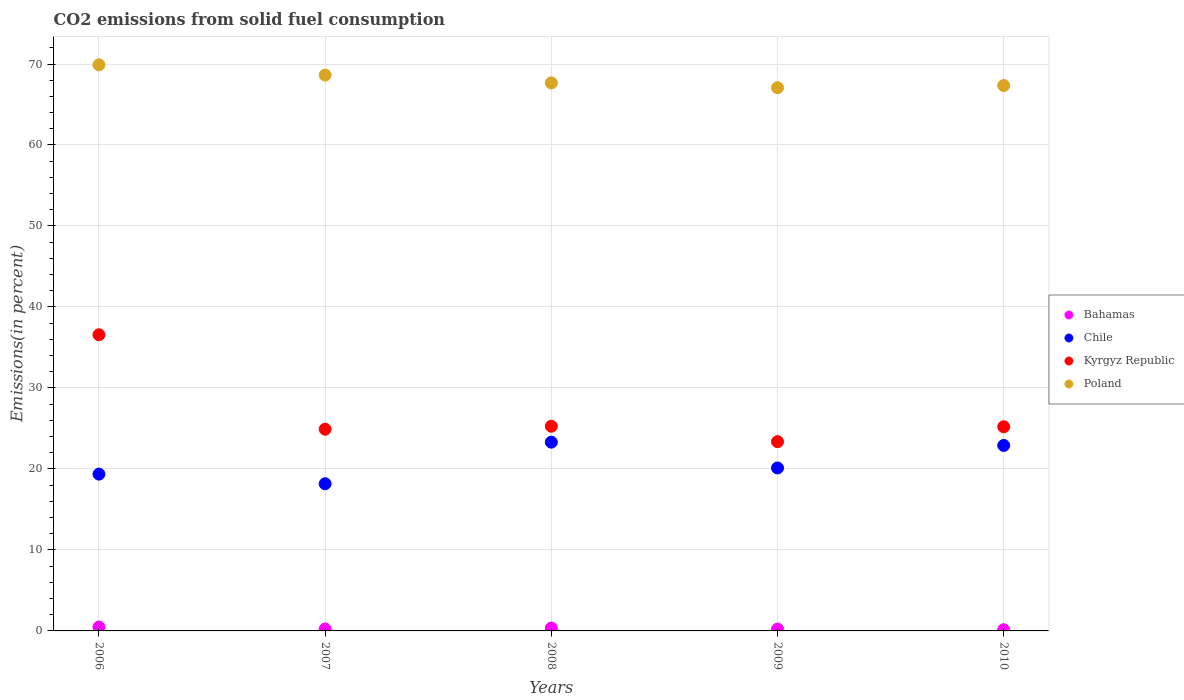What is the total CO2 emitted in Bahamas in 2007?
Offer a terse response. 0.24. Across all years, what is the maximum total CO2 emitted in Poland?
Your answer should be very brief. 69.9. Across all years, what is the minimum total CO2 emitted in Poland?
Keep it short and to the point. 67.08. In which year was the total CO2 emitted in Bahamas minimum?
Your response must be concise. 2010. What is the total total CO2 emitted in Kyrgyz Republic in the graph?
Provide a short and direct response. 135.33. What is the difference between the total CO2 emitted in Bahamas in 2006 and that in 2007?
Ensure brevity in your answer.  0.24. What is the difference between the total CO2 emitted in Kyrgyz Republic in 2008 and the total CO2 emitted in Bahamas in 2007?
Provide a short and direct response. 25.04. What is the average total CO2 emitted in Bahamas per year?
Offer a terse response. 0.29. In the year 2007, what is the difference between the total CO2 emitted in Poland and total CO2 emitted in Chile?
Offer a very short reply. 50.46. In how many years, is the total CO2 emitted in Poland greater than 4 %?
Your answer should be compact. 5. What is the ratio of the total CO2 emitted in Bahamas in 2006 to that in 2007?
Keep it short and to the point. 2.03. Is the difference between the total CO2 emitted in Poland in 2007 and 2009 greater than the difference between the total CO2 emitted in Chile in 2007 and 2009?
Make the answer very short. Yes. What is the difference between the highest and the second highest total CO2 emitted in Kyrgyz Republic?
Give a very brief answer. 11.3. What is the difference between the highest and the lowest total CO2 emitted in Poland?
Offer a very short reply. 2.82. In how many years, is the total CO2 emitted in Bahamas greater than the average total CO2 emitted in Bahamas taken over all years?
Ensure brevity in your answer.  2. Is the sum of the total CO2 emitted in Chile in 2008 and 2009 greater than the maximum total CO2 emitted in Poland across all years?
Your response must be concise. No. Is it the case that in every year, the sum of the total CO2 emitted in Bahamas and total CO2 emitted in Chile  is greater than the sum of total CO2 emitted in Poland and total CO2 emitted in Kyrgyz Republic?
Your answer should be very brief. No. Is it the case that in every year, the sum of the total CO2 emitted in Chile and total CO2 emitted in Kyrgyz Republic  is greater than the total CO2 emitted in Bahamas?
Keep it short and to the point. Yes. Is the total CO2 emitted in Poland strictly greater than the total CO2 emitted in Bahamas over the years?
Your answer should be very brief. Yes. How many dotlines are there?
Give a very brief answer. 4. Are the values on the major ticks of Y-axis written in scientific E-notation?
Offer a terse response. No. Where does the legend appear in the graph?
Your answer should be very brief. Center right. How are the legend labels stacked?
Give a very brief answer. Vertical. What is the title of the graph?
Provide a short and direct response. CO2 emissions from solid fuel consumption. What is the label or title of the X-axis?
Offer a very short reply. Years. What is the label or title of the Y-axis?
Provide a succinct answer. Emissions(in percent). What is the Emissions(in percent) of Bahamas in 2006?
Make the answer very short. 0.48. What is the Emissions(in percent) of Chile in 2006?
Keep it short and to the point. 19.36. What is the Emissions(in percent) in Kyrgyz Republic in 2006?
Your answer should be compact. 36.57. What is the Emissions(in percent) of Poland in 2006?
Provide a short and direct response. 69.9. What is the Emissions(in percent) in Bahamas in 2007?
Ensure brevity in your answer.  0.24. What is the Emissions(in percent) in Chile in 2007?
Your answer should be compact. 18.17. What is the Emissions(in percent) of Kyrgyz Republic in 2007?
Provide a short and direct response. 24.91. What is the Emissions(in percent) of Poland in 2007?
Offer a terse response. 68.63. What is the Emissions(in percent) of Bahamas in 2008?
Give a very brief answer. 0.35. What is the Emissions(in percent) in Chile in 2008?
Provide a short and direct response. 23.31. What is the Emissions(in percent) in Kyrgyz Republic in 2008?
Your answer should be very brief. 25.27. What is the Emissions(in percent) in Poland in 2008?
Keep it short and to the point. 67.67. What is the Emissions(in percent) in Bahamas in 2009?
Offer a very short reply. 0.22. What is the Emissions(in percent) of Chile in 2009?
Offer a terse response. 20.12. What is the Emissions(in percent) in Kyrgyz Republic in 2009?
Ensure brevity in your answer.  23.37. What is the Emissions(in percent) of Poland in 2009?
Your response must be concise. 67.08. What is the Emissions(in percent) of Bahamas in 2010?
Ensure brevity in your answer.  0.15. What is the Emissions(in percent) of Chile in 2010?
Your answer should be compact. 22.9. What is the Emissions(in percent) of Kyrgyz Republic in 2010?
Keep it short and to the point. 25.21. What is the Emissions(in percent) in Poland in 2010?
Give a very brief answer. 67.34. Across all years, what is the maximum Emissions(in percent) in Bahamas?
Make the answer very short. 0.48. Across all years, what is the maximum Emissions(in percent) in Chile?
Provide a succinct answer. 23.31. Across all years, what is the maximum Emissions(in percent) of Kyrgyz Republic?
Your response must be concise. 36.57. Across all years, what is the maximum Emissions(in percent) in Poland?
Offer a very short reply. 69.9. Across all years, what is the minimum Emissions(in percent) in Bahamas?
Ensure brevity in your answer.  0.15. Across all years, what is the minimum Emissions(in percent) in Chile?
Make the answer very short. 18.17. Across all years, what is the minimum Emissions(in percent) of Kyrgyz Republic?
Ensure brevity in your answer.  23.37. Across all years, what is the minimum Emissions(in percent) in Poland?
Give a very brief answer. 67.08. What is the total Emissions(in percent) in Bahamas in the graph?
Your answer should be very brief. 1.44. What is the total Emissions(in percent) in Chile in the graph?
Your answer should be compact. 103.87. What is the total Emissions(in percent) in Kyrgyz Republic in the graph?
Ensure brevity in your answer.  135.33. What is the total Emissions(in percent) of Poland in the graph?
Your response must be concise. 340.62. What is the difference between the Emissions(in percent) of Bahamas in 2006 and that in 2007?
Your answer should be compact. 0.24. What is the difference between the Emissions(in percent) of Chile in 2006 and that in 2007?
Give a very brief answer. 1.19. What is the difference between the Emissions(in percent) in Kyrgyz Republic in 2006 and that in 2007?
Your answer should be compact. 11.66. What is the difference between the Emissions(in percent) in Poland in 2006 and that in 2007?
Provide a short and direct response. 1.27. What is the difference between the Emissions(in percent) in Bahamas in 2006 and that in 2008?
Ensure brevity in your answer.  0.13. What is the difference between the Emissions(in percent) in Chile in 2006 and that in 2008?
Your response must be concise. -3.95. What is the difference between the Emissions(in percent) of Kyrgyz Republic in 2006 and that in 2008?
Provide a short and direct response. 11.3. What is the difference between the Emissions(in percent) of Poland in 2006 and that in 2008?
Your answer should be very brief. 2.23. What is the difference between the Emissions(in percent) in Bahamas in 2006 and that in 2009?
Ensure brevity in your answer.  0.26. What is the difference between the Emissions(in percent) in Chile in 2006 and that in 2009?
Ensure brevity in your answer.  -0.76. What is the difference between the Emissions(in percent) of Kyrgyz Republic in 2006 and that in 2009?
Provide a short and direct response. 13.2. What is the difference between the Emissions(in percent) of Poland in 2006 and that in 2009?
Your answer should be compact. 2.82. What is the difference between the Emissions(in percent) in Bahamas in 2006 and that in 2010?
Your answer should be compact. 0.33. What is the difference between the Emissions(in percent) in Chile in 2006 and that in 2010?
Provide a short and direct response. -3.54. What is the difference between the Emissions(in percent) of Kyrgyz Republic in 2006 and that in 2010?
Offer a very short reply. 11.36. What is the difference between the Emissions(in percent) of Poland in 2006 and that in 2010?
Offer a very short reply. 2.56. What is the difference between the Emissions(in percent) in Bahamas in 2007 and that in 2008?
Offer a very short reply. -0.11. What is the difference between the Emissions(in percent) in Chile in 2007 and that in 2008?
Your response must be concise. -5.14. What is the difference between the Emissions(in percent) of Kyrgyz Republic in 2007 and that in 2008?
Give a very brief answer. -0.37. What is the difference between the Emissions(in percent) of Poland in 2007 and that in 2008?
Your answer should be very brief. 0.97. What is the difference between the Emissions(in percent) in Bahamas in 2007 and that in 2009?
Provide a short and direct response. 0.01. What is the difference between the Emissions(in percent) in Chile in 2007 and that in 2009?
Your answer should be very brief. -1.95. What is the difference between the Emissions(in percent) of Kyrgyz Republic in 2007 and that in 2009?
Your response must be concise. 1.54. What is the difference between the Emissions(in percent) in Poland in 2007 and that in 2009?
Keep it short and to the point. 1.56. What is the difference between the Emissions(in percent) of Bahamas in 2007 and that in 2010?
Your answer should be very brief. 0.09. What is the difference between the Emissions(in percent) in Chile in 2007 and that in 2010?
Offer a terse response. -4.73. What is the difference between the Emissions(in percent) in Kyrgyz Republic in 2007 and that in 2010?
Give a very brief answer. -0.3. What is the difference between the Emissions(in percent) in Poland in 2007 and that in 2010?
Give a very brief answer. 1.29. What is the difference between the Emissions(in percent) in Bahamas in 2008 and that in 2009?
Your answer should be very brief. 0.13. What is the difference between the Emissions(in percent) in Chile in 2008 and that in 2009?
Your answer should be very brief. 3.19. What is the difference between the Emissions(in percent) of Kyrgyz Republic in 2008 and that in 2009?
Give a very brief answer. 1.9. What is the difference between the Emissions(in percent) of Poland in 2008 and that in 2009?
Provide a succinct answer. 0.59. What is the difference between the Emissions(in percent) of Bahamas in 2008 and that in 2010?
Your answer should be compact. 0.2. What is the difference between the Emissions(in percent) in Chile in 2008 and that in 2010?
Your answer should be very brief. 0.41. What is the difference between the Emissions(in percent) of Kyrgyz Republic in 2008 and that in 2010?
Your response must be concise. 0.07. What is the difference between the Emissions(in percent) of Poland in 2008 and that in 2010?
Your answer should be compact. 0.32. What is the difference between the Emissions(in percent) in Bahamas in 2009 and that in 2010?
Provide a short and direct response. 0.07. What is the difference between the Emissions(in percent) in Chile in 2009 and that in 2010?
Give a very brief answer. -2.78. What is the difference between the Emissions(in percent) of Kyrgyz Republic in 2009 and that in 2010?
Your response must be concise. -1.84. What is the difference between the Emissions(in percent) in Poland in 2009 and that in 2010?
Your response must be concise. -0.27. What is the difference between the Emissions(in percent) of Bahamas in 2006 and the Emissions(in percent) of Chile in 2007?
Offer a terse response. -17.69. What is the difference between the Emissions(in percent) in Bahamas in 2006 and the Emissions(in percent) in Kyrgyz Republic in 2007?
Ensure brevity in your answer.  -24.42. What is the difference between the Emissions(in percent) in Bahamas in 2006 and the Emissions(in percent) in Poland in 2007?
Your answer should be very brief. -68.15. What is the difference between the Emissions(in percent) of Chile in 2006 and the Emissions(in percent) of Kyrgyz Republic in 2007?
Ensure brevity in your answer.  -5.55. What is the difference between the Emissions(in percent) of Chile in 2006 and the Emissions(in percent) of Poland in 2007?
Ensure brevity in your answer.  -49.27. What is the difference between the Emissions(in percent) in Kyrgyz Republic in 2006 and the Emissions(in percent) in Poland in 2007?
Your answer should be compact. -32.06. What is the difference between the Emissions(in percent) of Bahamas in 2006 and the Emissions(in percent) of Chile in 2008?
Offer a very short reply. -22.83. What is the difference between the Emissions(in percent) in Bahamas in 2006 and the Emissions(in percent) in Kyrgyz Republic in 2008?
Give a very brief answer. -24.79. What is the difference between the Emissions(in percent) of Bahamas in 2006 and the Emissions(in percent) of Poland in 2008?
Ensure brevity in your answer.  -67.18. What is the difference between the Emissions(in percent) of Chile in 2006 and the Emissions(in percent) of Kyrgyz Republic in 2008?
Ensure brevity in your answer.  -5.91. What is the difference between the Emissions(in percent) in Chile in 2006 and the Emissions(in percent) in Poland in 2008?
Offer a very short reply. -48.31. What is the difference between the Emissions(in percent) in Kyrgyz Republic in 2006 and the Emissions(in percent) in Poland in 2008?
Your response must be concise. -31.1. What is the difference between the Emissions(in percent) in Bahamas in 2006 and the Emissions(in percent) in Chile in 2009?
Provide a short and direct response. -19.64. What is the difference between the Emissions(in percent) in Bahamas in 2006 and the Emissions(in percent) in Kyrgyz Republic in 2009?
Keep it short and to the point. -22.89. What is the difference between the Emissions(in percent) in Bahamas in 2006 and the Emissions(in percent) in Poland in 2009?
Keep it short and to the point. -66.59. What is the difference between the Emissions(in percent) in Chile in 2006 and the Emissions(in percent) in Kyrgyz Republic in 2009?
Your answer should be compact. -4.01. What is the difference between the Emissions(in percent) of Chile in 2006 and the Emissions(in percent) of Poland in 2009?
Offer a terse response. -47.72. What is the difference between the Emissions(in percent) in Kyrgyz Republic in 2006 and the Emissions(in percent) in Poland in 2009?
Provide a succinct answer. -30.51. What is the difference between the Emissions(in percent) in Bahamas in 2006 and the Emissions(in percent) in Chile in 2010?
Ensure brevity in your answer.  -22.42. What is the difference between the Emissions(in percent) of Bahamas in 2006 and the Emissions(in percent) of Kyrgyz Republic in 2010?
Provide a succinct answer. -24.73. What is the difference between the Emissions(in percent) of Bahamas in 2006 and the Emissions(in percent) of Poland in 2010?
Give a very brief answer. -66.86. What is the difference between the Emissions(in percent) in Chile in 2006 and the Emissions(in percent) in Kyrgyz Republic in 2010?
Keep it short and to the point. -5.85. What is the difference between the Emissions(in percent) of Chile in 2006 and the Emissions(in percent) of Poland in 2010?
Ensure brevity in your answer.  -47.98. What is the difference between the Emissions(in percent) of Kyrgyz Republic in 2006 and the Emissions(in percent) of Poland in 2010?
Keep it short and to the point. -30.77. What is the difference between the Emissions(in percent) of Bahamas in 2007 and the Emissions(in percent) of Chile in 2008?
Give a very brief answer. -23.07. What is the difference between the Emissions(in percent) in Bahamas in 2007 and the Emissions(in percent) in Kyrgyz Republic in 2008?
Keep it short and to the point. -25.04. What is the difference between the Emissions(in percent) in Bahamas in 2007 and the Emissions(in percent) in Poland in 2008?
Provide a short and direct response. -67.43. What is the difference between the Emissions(in percent) in Chile in 2007 and the Emissions(in percent) in Kyrgyz Republic in 2008?
Your answer should be compact. -7.1. What is the difference between the Emissions(in percent) in Chile in 2007 and the Emissions(in percent) in Poland in 2008?
Offer a very short reply. -49.49. What is the difference between the Emissions(in percent) in Kyrgyz Republic in 2007 and the Emissions(in percent) in Poland in 2008?
Your response must be concise. -42.76. What is the difference between the Emissions(in percent) of Bahamas in 2007 and the Emissions(in percent) of Chile in 2009?
Make the answer very short. -19.89. What is the difference between the Emissions(in percent) of Bahamas in 2007 and the Emissions(in percent) of Kyrgyz Republic in 2009?
Provide a short and direct response. -23.13. What is the difference between the Emissions(in percent) in Bahamas in 2007 and the Emissions(in percent) in Poland in 2009?
Make the answer very short. -66.84. What is the difference between the Emissions(in percent) of Chile in 2007 and the Emissions(in percent) of Kyrgyz Republic in 2009?
Give a very brief answer. -5.2. What is the difference between the Emissions(in percent) in Chile in 2007 and the Emissions(in percent) in Poland in 2009?
Make the answer very short. -48.9. What is the difference between the Emissions(in percent) in Kyrgyz Republic in 2007 and the Emissions(in percent) in Poland in 2009?
Provide a succinct answer. -42.17. What is the difference between the Emissions(in percent) of Bahamas in 2007 and the Emissions(in percent) of Chile in 2010?
Make the answer very short. -22.67. What is the difference between the Emissions(in percent) of Bahamas in 2007 and the Emissions(in percent) of Kyrgyz Republic in 2010?
Your answer should be compact. -24.97. What is the difference between the Emissions(in percent) in Bahamas in 2007 and the Emissions(in percent) in Poland in 2010?
Your answer should be very brief. -67.11. What is the difference between the Emissions(in percent) in Chile in 2007 and the Emissions(in percent) in Kyrgyz Republic in 2010?
Your response must be concise. -7.04. What is the difference between the Emissions(in percent) of Chile in 2007 and the Emissions(in percent) of Poland in 2010?
Make the answer very short. -49.17. What is the difference between the Emissions(in percent) in Kyrgyz Republic in 2007 and the Emissions(in percent) in Poland in 2010?
Your answer should be very brief. -42.44. What is the difference between the Emissions(in percent) in Bahamas in 2008 and the Emissions(in percent) in Chile in 2009?
Provide a short and direct response. -19.77. What is the difference between the Emissions(in percent) of Bahamas in 2008 and the Emissions(in percent) of Kyrgyz Republic in 2009?
Give a very brief answer. -23.02. What is the difference between the Emissions(in percent) in Bahamas in 2008 and the Emissions(in percent) in Poland in 2009?
Ensure brevity in your answer.  -66.72. What is the difference between the Emissions(in percent) in Chile in 2008 and the Emissions(in percent) in Kyrgyz Republic in 2009?
Offer a very short reply. -0.06. What is the difference between the Emissions(in percent) of Chile in 2008 and the Emissions(in percent) of Poland in 2009?
Give a very brief answer. -43.77. What is the difference between the Emissions(in percent) of Kyrgyz Republic in 2008 and the Emissions(in percent) of Poland in 2009?
Your response must be concise. -41.8. What is the difference between the Emissions(in percent) in Bahamas in 2008 and the Emissions(in percent) in Chile in 2010?
Offer a very short reply. -22.55. What is the difference between the Emissions(in percent) in Bahamas in 2008 and the Emissions(in percent) in Kyrgyz Republic in 2010?
Ensure brevity in your answer.  -24.86. What is the difference between the Emissions(in percent) of Bahamas in 2008 and the Emissions(in percent) of Poland in 2010?
Your answer should be compact. -66.99. What is the difference between the Emissions(in percent) in Chile in 2008 and the Emissions(in percent) in Kyrgyz Republic in 2010?
Your answer should be compact. -1.9. What is the difference between the Emissions(in percent) in Chile in 2008 and the Emissions(in percent) in Poland in 2010?
Give a very brief answer. -44.03. What is the difference between the Emissions(in percent) of Kyrgyz Republic in 2008 and the Emissions(in percent) of Poland in 2010?
Offer a terse response. -42.07. What is the difference between the Emissions(in percent) in Bahamas in 2009 and the Emissions(in percent) in Chile in 2010?
Provide a short and direct response. -22.68. What is the difference between the Emissions(in percent) in Bahamas in 2009 and the Emissions(in percent) in Kyrgyz Republic in 2010?
Give a very brief answer. -24.99. What is the difference between the Emissions(in percent) in Bahamas in 2009 and the Emissions(in percent) in Poland in 2010?
Provide a short and direct response. -67.12. What is the difference between the Emissions(in percent) in Chile in 2009 and the Emissions(in percent) in Kyrgyz Republic in 2010?
Provide a short and direct response. -5.09. What is the difference between the Emissions(in percent) of Chile in 2009 and the Emissions(in percent) of Poland in 2010?
Keep it short and to the point. -47.22. What is the difference between the Emissions(in percent) of Kyrgyz Republic in 2009 and the Emissions(in percent) of Poland in 2010?
Your answer should be very brief. -43.97. What is the average Emissions(in percent) of Bahamas per year?
Offer a very short reply. 0.29. What is the average Emissions(in percent) in Chile per year?
Offer a very short reply. 20.77. What is the average Emissions(in percent) in Kyrgyz Republic per year?
Your answer should be very brief. 27.07. What is the average Emissions(in percent) of Poland per year?
Provide a succinct answer. 68.12. In the year 2006, what is the difference between the Emissions(in percent) in Bahamas and Emissions(in percent) in Chile?
Give a very brief answer. -18.88. In the year 2006, what is the difference between the Emissions(in percent) of Bahamas and Emissions(in percent) of Kyrgyz Republic?
Offer a terse response. -36.09. In the year 2006, what is the difference between the Emissions(in percent) of Bahamas and Emissions(in percent) of Poland?
Provide a short and direct response. -69.42. In the year 2006, what is the difference between the Emissions(in percent) of Chile and Emissions(in percent) of Kyrgyz Republic?
Provide a short and direct response. -17.21. In the year 2006, what is the difference between the Emissions(in percent) in Chile and Emissions(in percent) in Poland?
Your answer should be compact. -50.54. In the year 2006, what is the difference between the Emissions(in percent) in Kyrgyz Republic and Emissions(in percent) in Poland?
Your response must be concise. -33.33. In the year 2007, what is the difference between the Emissions(in percent) in Bahamas and Emissions(in percent) in Chile?
Your answer should be very brief. -17.93. In the year 2007, what is the difference between the Emissions(in percent) of Bahamas and Emissions(in percent) of Kyrgyz Republic?
Your response must be concise. -24.67. In the year 2007, what is the difference between the Emissions(in percent) in Bahamas and Emissions(in percent) in Poland?
Offer a terse response. -68.4. In the year 2007, what is the difference between the Emissions(in percent) in Chile and Emissions(in percent) in Kyrgyz Republic?
Ensure brevity in your answer.  -6.74. In the year 2007, what is the difference between the Emissions(in percent) of Chile and Emissions(in percent) of Poland?
Your answer should be compact. -50.46. In the year 2007, what is the difference between the Emissions(in percent) of Kyrgyz Republic and Emissions(in percent) of Poland?
Offer a terse response. -43.73. In the year 2008, what is the difference between the Emissions(in percent) in Bahamas and Emissions(in percent) in Chile?
Keep it short and to the point. -22.96. In the year 2008, what is the difference between the Emissions(in percent) in Bahamas and Emissions(in percent) in Kyrgyz Republic?
Keep it short and to the point. -24.92. In the year 2008, what is the difference between the Emissions(in percent) of Bahamas and Emissions(in percent) of Poland?
Your response must be concise. -67.32. In the year 2008, what is the difference between the Emissions(in percent) in Chile and Emissions(in percent) in Kyrgyz Republic?
Give a very brief answer. -1.97. In the year 2008, what is the difference between the Emissions(in percent) of Chile and Emissions(in percent) of Poland?
Offer a terse response. -44.36. In the year 2008, what is the difference between the Emissions(in percent) of Kyrgyz Republic and Emissions(in percent) of Poland?
Your answer should be compact. -42.39. In the year 2009, what is the difference between the Emissions(in percent) of Bahamas and Emissions(in percent) of Chile?
Provide a succinct answer. -19.9. In the year 2009, what is the difference between the Emissions(in percent) of Bahamas and Emissions(in percent) of Kyrgyz Republic?
Ensure brevity in your answer.  -23.15. In the year 2009, what is the difference between the Emissions(in percent) in Bahamas and Emissions(in percent) in Poland?
Your response must be concise. -66.85. In the year 2009, what is the difference between the Emissions(in percent) in Chile and Emissions(in percent) in Kyrgyz Republic?
Provide a succinct answer. -3.25. In the year 2009, what is the difference between the Emissions(in percent) in Chile and Emissions(in percent) in Poland?
Your answer should be compact. -46.95. In the year 2009, what is the difference between the Emissions(in percent) of Kyrgyz Republic and Emissions(in percent) of Poland?
Provide a short and direct response. -43.71. In the year 2010, what is the difference between the Emissions(in percent) of Bahamas and Emissions(in percent) of Chile?
Give a very brief answer. -22.75. In the year 2010, what is the difference between the Emissions(in percent) of Bahamas and Emissions(in percent) of Kyrgyz Republic?
Provide a succinct answer. -25.06. In the year 2010, what is the difference between the Emissions(in percent) in Bahamas and Emissions(in percent) in Poland?
Offer a terse response. -67.19. In the year 2010, what is the difference between the Emissions(in percent) of Chile and Emissions(in percent) of Kyrgyz Republic?
Give a very brief answer. -2.31. In the year 2010, what is the difference between the Emissions(in percent) of Chile and Emissions(in percent) of Poland?
Your response must be concise. -44.44. In the year 2010, what is the difference between the Emissions(in percent) of Kyrgyz Republic and Emissions(in percent) of Poland?
Keep it short and to the point. -42.13. What is the ratio of the Emissions(in percent) of Bahamas in 2006 to that in 2007?
Offer a terse response. 2.03. What is the ratio of the Emissions(in percent) of Chile in 2006 to that in 2007?
Your response must be concise. 1.07. What is the ratio of the Emissions(in percent) in Kyrgyz Republic in 2006 to that in 2007?
Offer a terse response. 1.47. What is the ratio of the Emissions(in percent) in Poland in 2006 to that in 2007?
Offer a terse response. 1.02. What is the ratio of the Emissions(in percent) in Bahamas in 2006 to that in 2008?
Ensure brevity in your answer.  1.37. What is the ratio of the Emissions(in percent) of Chile in 2006 to that in 2008?
Make the answer very short. 0.83. What is the ratio of the Emissions(in percent) of Kyrgyz Republic in 2006 to that in 2008?
Give a very brief answer. 1.45. What is the ratio of the Emissions(in percent) of Poland in 2006 to that in 2008?
Offer a terse response. 1.03. What is the ratio of the Emissions(in percent) of Bahamas in 2006 to that in 2009?
Your answer should be very brief. 2.16. What is the ratio of the Emissions(in percent) in Chile in 2006 to that in 2009?
Provide a short and direct response. 0.96. What is the ratio of the Emissions(in percent) in Kyrgyz Republic in 2006 to that in 2009?
Your answer should be compact. 1.56. What is the ratio of the Emissions(in percent) of Poland in 2006 to that in 2009?
Provide a short and direct response. 1.04. What is the ratio of the Emissions(in percent) in Bahamas in 2006 to that in 2010?
Offer a very short reply. 3.24. What is the ratio of the Emissions(in percent) of Chile in 2006 to that in 2010?
Make the answer very short. 0.85. What is the ratio of the Emissions(in percent) of Kyrgyz Republic in 2006 to that in 2010?
Keep it short and to the point. 1.45. What is the ratio of the Emissions(in percent) in Poland in 2006 to that in 2010?
Keep it short and to the point. 1.04. What is the ratio of the Emissions(in percent) in Bahamas in 2007 to that in 2008?
Offer a terse response. 0.68. What is the ratio of the Emissions(in percent) in Chile in 2007 to that in 2008?
Your answer should be compact. 0.78. What is the ratio of the Emissions(in percent) of Kyrgyz Republic in 2007 to that in 2008?
Offer a terse response. 0.99. What is the ratio of the Emissions(in percent) in Poland in 2007 to that in 2008?
Keep it short and to the point. 1.01. What is the ratio of the Emissions(in percent) in Bahamas in 2007 to that in 2009?
Make the answer very short. 1.06. What is the ratio of the Emissions(in percent) of Chile in 2007 to that in 2009?
Your answer should be compact. 0.9. What is the ratio of the Emissions(in percent) of Kyrgyz Republic in 2007 to that in 2009?
Provide a succinct answer. 1.07. What is the ratio of the Emissions(in percent) of Poland in 2007 to that in 2009?
Your answer should be compact. 1.02. What is the ratio of the Emissions(in percent) of Bahamas in 2007 to that in 2010?
Your answer should be compact. 1.59. What is the ratio of the Emissions(in percent) of Chile in 2007 to that in 2010?
Ensure brevity in your answer.  0.79. What is the ratio of the Emissions(in percent) of Poland in 2007 to that in 2010?
Make the answer very short. 1.02. What is the ratio of the Emissions(in percent) of Bahamas in 2008 to that in 2009?
Provide a succinct answer. 1.57. What is the ratio of the Emissions(in percent) in Chile in 2008 to that in 2009?
Your answer should be very brief. 1.16. What is the ratio of the Emissions(in percent) in Kyrgyz Republic in 2008 to that in 2009?
Provide a succinct answer. 1.08. What is the ratio of the Emissions(in percent) of Poland in 2008 to that in 2009?
Offer a very short reply. 1.01. What is the ratio of the Emissions(in percent) in Bahamas in 2008 to that in 2010?
Your answer should be very brief. 2.36. What is the ratio of the Emissions(in percent) of Chile in 2008 to that in 2010?
Your answer should be compact. 1.02. What is the ratio of the Emissions(in percent) in Poland in 2008 to that in 2010?
Offer a very short reply. 1. What is the ratio of the Emissions(in percent) of Bahamas in 2009 to that in 2010?
Provide a succinct answer. 1.5. What is the ratio of the Emissions(in percent) in Chile in 2009 to that in 2010?
Your answer should be very brief. 0.88. What is the ratio of the Emissions(in percent) in Kyrgyz Republic in 2009 to that in 2010?
Provide a succinct answer. 0.93. What is the difference between the highest and the second highest Emissions(in percent) of Bahamas?
Give a very brief answer. 0.13. What is the difference between the highest and the second highest Emissions(in percent) in Chile?
Ensure brevity in your answer.  0.41. What is the difference between the highest and the second highest Emissions(in percent) in Kyrgyz Republic?
Ensure brevity in your answer.  11.3. What is the difference between the highest and the second highest Emissions(in percent) in Poland?
Provide a short and direct response. 1.27. What is the difference between the highest and the lowest Emissions(in percent) of Bahamas?
Your answer should be very brief. 0.33. What is the difference between the highest and the lowest Emissions(in percent) in Chile?
Your answer should be compact. 5.14. What is the difference between the highest and the lowest Emissions(in percent) of Kyrgyz Republic?
Ensure brevity in your answer.  13.2. What is the difference between the highest and the lowest Emissions(in percent) of Poland?
Keep it short and to the point. 2.82. 